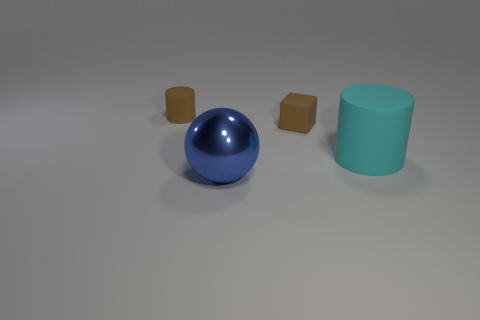Subtract all red cylinders. Subtract all green balls. How many cylinders are left? 2 Add 2 brown cylinders. How many objects exist? 6 Subtract all blocks. How many objects are left? 3 Subtract 0 gray spheres. How many objects are left? 4 Subtract all big cylinders. Subtract all blue objects. How many objects are left? 2 Add 4 tiny brown cylinders. How many tiny brown cylinders are left? 5 Add 3 brown rubber things. How many brown rubber things exist? 5 